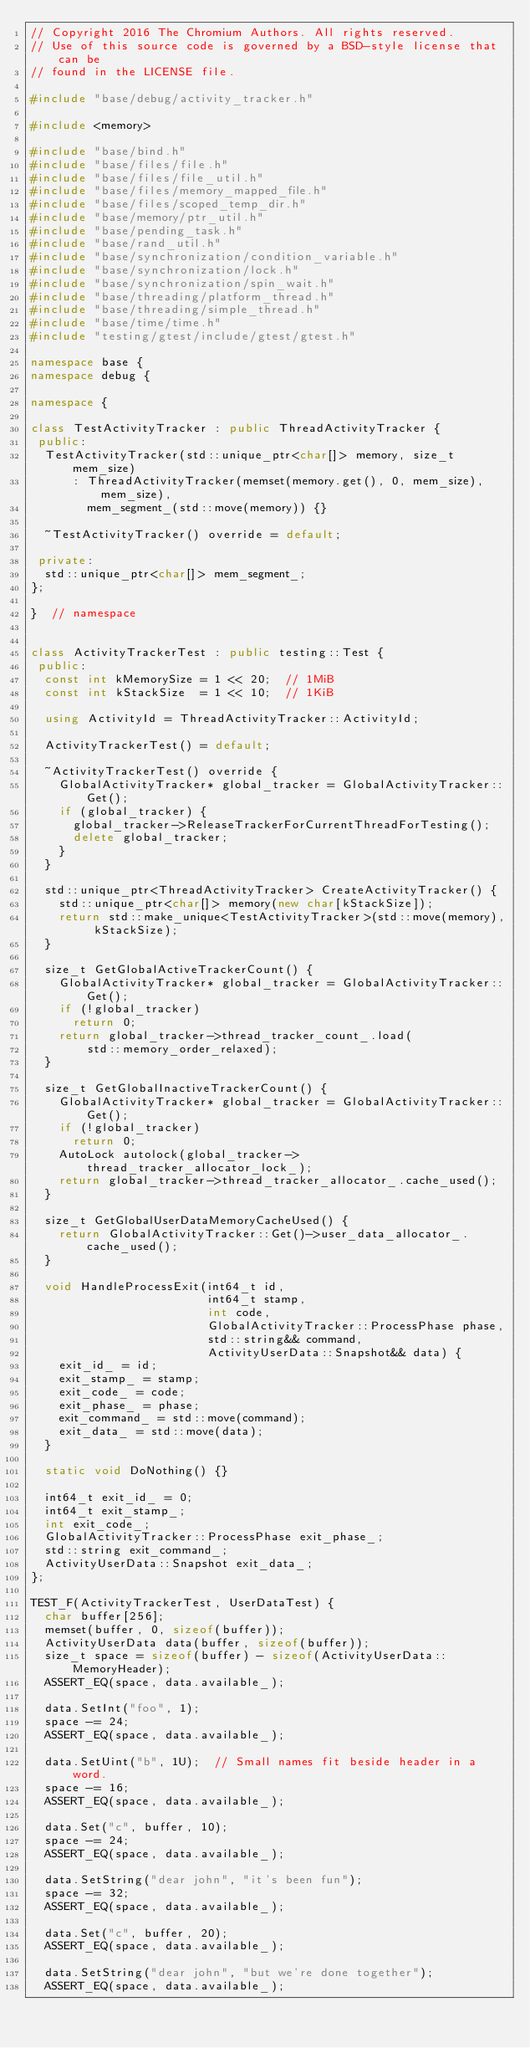Convert code to text. <code><loc_0><loc_0><loc_500><loc_500><_C++_>// Copyright 2016 The Chromium Authors. All rights reserved.
// Use of this source code is governed by a BSD-style license that can be
// found in the LICENSE file.

#include "base/debug/activity_tracker.h"

#include <memory>

#include "base/bind.h"
#include "base/files/file.h"
#include "base/files/file_util.h"
#include "base/files/memory_mapped_file.h"
#include "base/files/scoped_temp_dir.h"
#include "base/memory/ptr_util.h"
#include "base/pending_task.h"
#include "base/rand_util.h"
#include "base/synchronization/condition_variable.h"
#include "base/synchronization/lock.h"
#include "base/synchronization/spin_wait.h"
#include "base/threading/platform_thread.h"
#include "base/threading/simple_thread.h"
#include "base/time/time.h"
#include "testing/gtest/include/gtest/gtest.h"

namespace base {
namespace debug {

namespace {

class TestActivityTracker : public ThreadActivityTracker {
 public:
  TestActivityTracker(std::unique_ptr<char[]> memory, size_t mem_size)
      : ThreadActivityTracker(memset(memory.get(), 0, mem_size), mem_size),
        mem_segment_(std::move(memory)) {}

  ~TestActivityTracker() override = default;

 private:
  std::unique_ptr<char[]> mem_segment_;
};

}  // namespace


class ActivityTrackerTest : public testing::Test {
 public:
  const int kMemorySize = 1 << 20;  // 1MiB
  const int kStackSize  = 1 << 10;  // 1KiB

  using ActivityId = ThreadActivityTracker::ActivityId;

  ActivityTrackerTest() = default;

  ~ActivityTrackerTest() override {
    GlobalActivityTracker* global_tracker = GlobalActivityTracker::Get();
    if (global_tracker) {
      global_tracker->ReleaseTrackerForCurrentThreadForTesting();
      delete global_tracker;
    }
  }

  std::unique_ptr<ThreadActivityTracker> CreateActivityTracker() {
    std::unique_ptr<char[]> memory(new char[kStackSize]);
    return std::make_unique<TestActivityTracker>(std::move(memory), kStackSize);
  }

  size_t GetGlobalActiveTrackerCount() {
    GlobalActivityTracker* global_tracker = GlobalActivityTracker::Get();
    if (!global_tracker)
      return 0;
    return global_tracker->thread_tracker_count_.load(
        std::memory_order_relaxed);
  }

  size_t GetGlobalInactiveTrackerCount() {
    GlobalActivityTracker* global_tracker = GlobalActivityTracker::Get();
    if (!global_tracker)
      return 0;
    AutoLock autolock(global_tracker->thread_tracker_allocator_lock_);
    return global_tracker->thread_tracker_allocator_.cache_used();
  }

  size_t GetGlobalUserDataMemoryCacheUsed() {
    return GlobalActivityTracker::Get()->user_data_allocator_.cache_used();
  }

  void HandleProcessExit(int64_t id,
                         int64_t stamp,
                         int code,
                         GlobalActivityTracker::ProcessPhase phase,
                         std::string&& command,
                         ActivityUserData::Snapshot&& data) {
    exit_id_ = id;
    exit_stamp_ = stamp;
    exit_code_ = code;
    exit_phase_ = phase;
    exit_command_ = std::move(command);
    exit_data_ = std::move(data);
  }

  static void DoNothing() {}

  int64_t exit_id_ = 0;
  int64_t exit_stamp_;
  int exit_code_;
  GlobalActivityTracker::ProcessPhase exit_phase_;
  std::string exit_command_;
  ActivityUserData::Snapshot exit_data_;
};

TEST_F(ActivityTrackerTest, UserDataTest) {
  char buffer[256];
  memset(buffer, 0, sizeof(buffer));
  ActivityUserData data(buffer, sizeof(buffer));
  size_t space = sizeof(buffer) - sizeof(ActivityUserData::MemoryHeader);
  ASSERT_EQ(space, data.available_);

  data.SetInt("foo", 1);
  space -= 24;
  ASSERT_EQ(space, data.available_);

  data.SetUint("b", 1U);  // Small names fit beside header in a word.
  space -= 16;
  ASSERT_EQ(space, data.available_);

  data.Set("c", buffer, 10);
  space -= 24;
  ASSERT_EQ(space, data.available_);

  data.SetString("dear john", "it's been fun");
  space -= 32;
  ASSERT_EQ(space, data.available_);

  data.Set("c", buffer, 20);
  ASSERT_EQ(space, data.available_);

  data.SetString("dear john", "but we're done together");
  ASSERT_EQ(space, data.available_);
</code> 